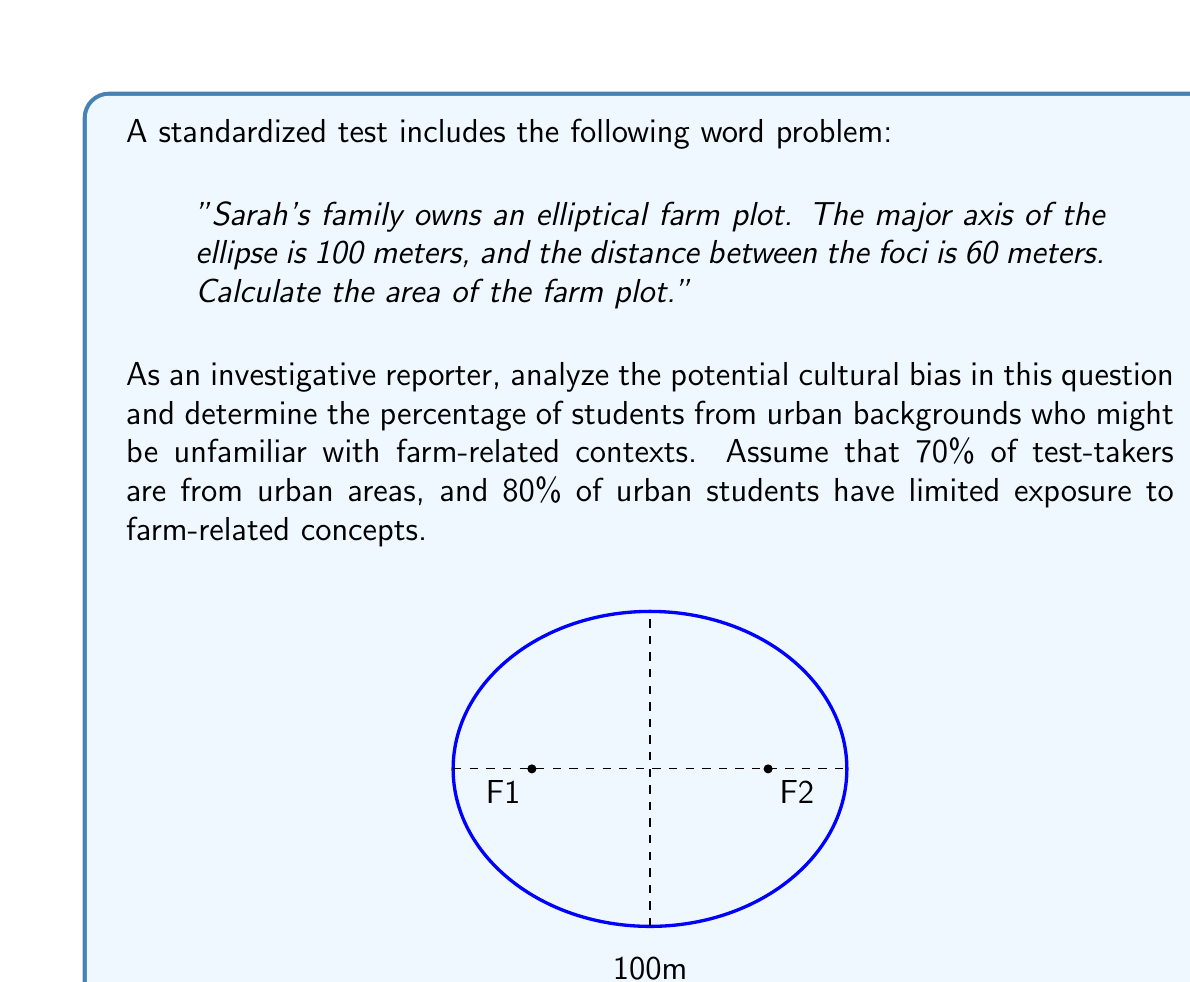Teach me how to tackle this problem. To analyze the cultural bias and calculate the percentage of students who might be unfamiliar with the context:

1. Identify the potentially biased elements:
   - Farm-related context
   - Elliptical shape of land (uncommon in urban settings)

2. Calculate the percentage of urban students unfamiliar with the context:
   - Total urban students: 70% of test-takers
   - Urban students unfamiliar with farm concepts: 80% of urban students
   - Percentage of all students unfamiliar: $0.70 \times 0.80 = 0.56$ or 56%

3. Consider the impact on problem-solving:
   - Students unfamiliar with farm contexts may struggle to visualize the problem
   - The elliptical shape might be less intuitive for urban students

4. Evaluate the mathematical content:
   - The problem involves calculating the area of an ellipse
   - Area of an ellipse: $A = \pi ab$, where $a$ and $b$ are semi-major and semi-minor axes

5. Calculate the semi-minor axis $b$:
   - Major axis $2a = 100$ m, so $a = 50$ m
   - Distance between foci $2c = 60$ m, so $c = 30$ m
   - Using $a^2 = b^2 + c^2$:
     $50^2 = b^2 + 30^2$
     $2500 = b^2 + 900$
     $b^2 = 1600$
     $b = 40$ m

6. Calculate the area:
   $A = \pi ab = \pi(50)(40) = 2000\pi \approx 6283.19$ sq meters

While the mathematical content is sound, the context potentially disadvantages 56% of students due to cultural bias.
Answer: 56% of students potentially disadvantaged 